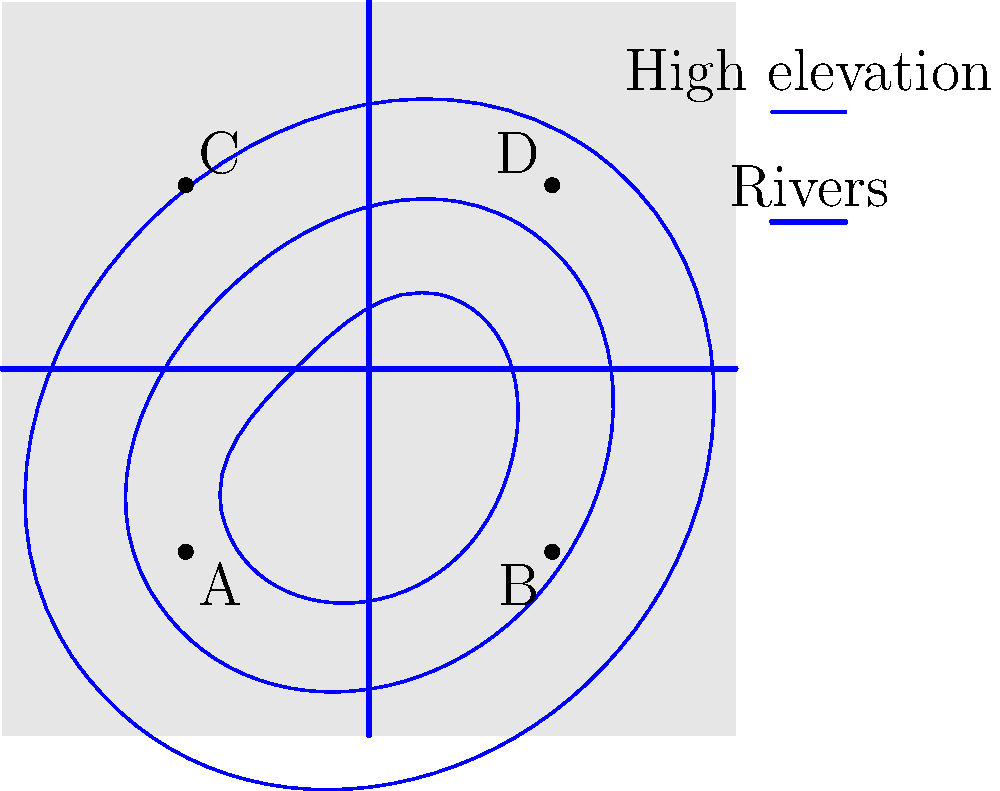Based on the topographical map of the city, which location (A, B, C, or D) would be the most effective for implementing a large-scale stormwater management system to mitigate urban flooding? To determine the most effective location for a stormwater management system, we need to consider the following factors:

1. Elevation: Lower elevations are generally better for collecting stormwater.
2. Proximity to water bodies: Areas near rivers can help with drainage.
3. Centrality: A central location can serve a larger area.

Analyzing the map:

1. Elevation analysis:
   - The blue lines represent elevation contours, with areas inside smaller contours having lower elevation.
   - Locations A and B are at higher elevations compared to C and D.

2. Proximity to rivers:
   - Two rivers intersect at the center of the city.
   - All four locations are relatively close to at least one river, but C and D are closer to the intersection.

3. Centrality:
   - All locations are somewhat central, but C and D are closer to the city center.

4. Comparing C and D:
   - C is at a slightly lower elevation than D, as it's closer to the center of the innermost contour.
   - C is equidistant from both rivers, while D is closer to one river but farther from the other.

Therefore, location C would be the most effective for implementing a large-scale stormwater management system because:
- It's at the lowest elevation among the options, allowing for better water collection.
- It's centrally located, serving a larger area of the city.
- It's equidistant from both rivers, providing balanced drainage options.
Answer: C 